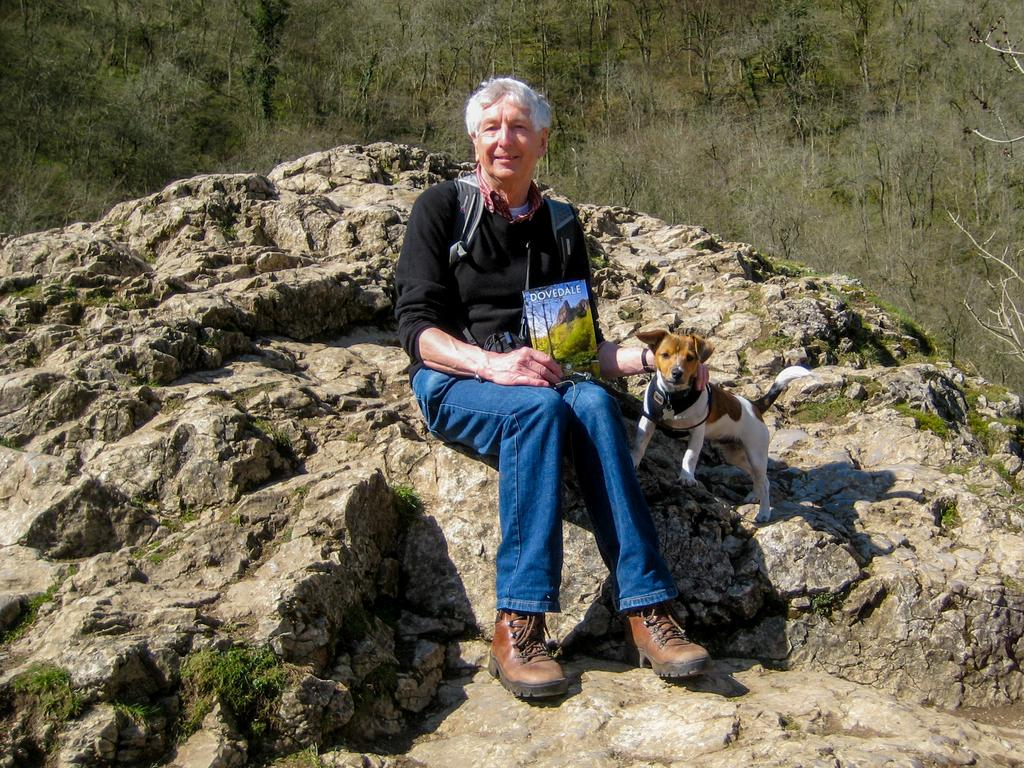What is the man in the image doing? The man is sitting in the center of the image. What is the man holding in his hand? The man is holding a book in his hand. Is there any other living creature in the image besides the man? Yes, there is a dog next to the man. What can be seen in the background of the image? There are trees and rocks in the background of the image. Reasoning: Let'g: Let's think step by step in order to produce the conversation. We start by identifying the main subject in the image, which is the man sitting in the center. Then, we describe what the man is doing and what he is holding, which is a book. Next, we mention the presence of the dog, as it is another living creature in the image. Finally, we describe the background of the image, which includes trees and rocks. Absurd Question/Answer: What type of toys can be seen in the image? There are no toys present in the image. How many eyes does the dog have in the image? The image does not show the dog's eyes, so it is not possible to determine how many eyes the dog has. 